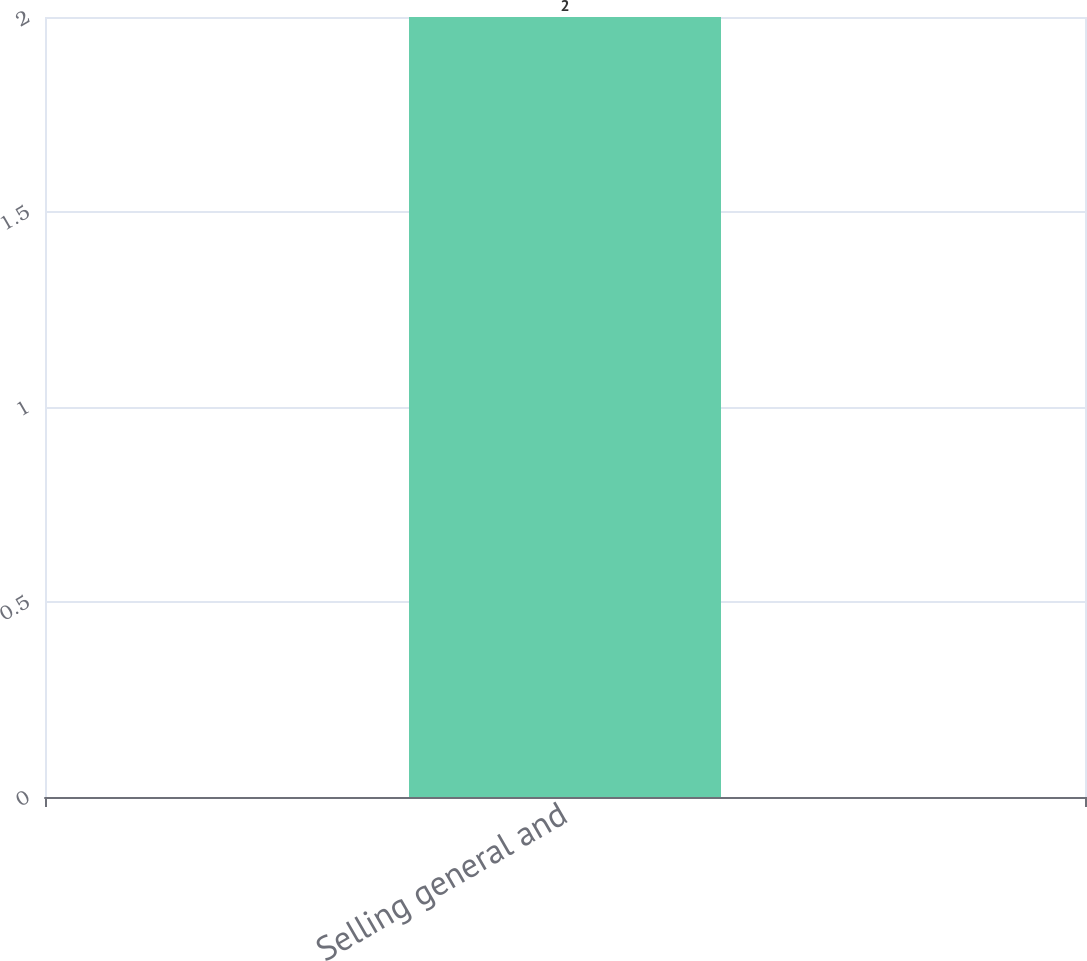<chart> <loc_0><loc_0><loc_500><loc_500><bar_chart><fcel>Selling general and<nl><fcel>2<nl></chart> 